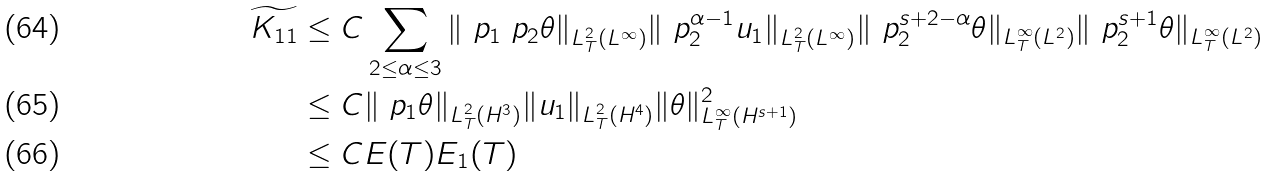Convert formula to latex. <formula><loc_0><loc_0><loc_500><loc_500>\widetilde { K _ { 1 1 } } \leq & \ C \sum _ { 2 \leq \alpha \leq 3 } \| \ p _ { 1 } \ p _ { 2 } \theta \| _ { L ^ { 2 } _ { T } ( L ^ { \infty } ) } \| \ p _ { 2 } ^ { \alpha - 1 } u _ { 1 } \| _ { L ^ { 2 } _ { T } ( L ^ { \infty } ) } \| \ p _ { 2 } ^ { s + 2 - \alpha } \theta \| _ { L ^ { \infty } _ { T } ( L ^ { 2 } ) } \| \ p _ { 2 } ^ { s + 1 } \theta \| _ { L ^ { \infty } _ { T } ( L ^ { 2 } ) } \\ \leq & \ C \| \ p _ { 1 } \theta \| _ { L ^ { 2 } _ { T } ( H ^ { 3 } ) } \| u _ { 1 } \| _ { L ^ { 2 } _ { T } ( H ^ { 4 } ) } \| \theta \| _ { L ^ { \infty } _ { T } ( H ^ { s + 1 } ) } ^ { 2 } \\ \leq & \ C E ( T ) E _ { 1 } ( T )</formula> 